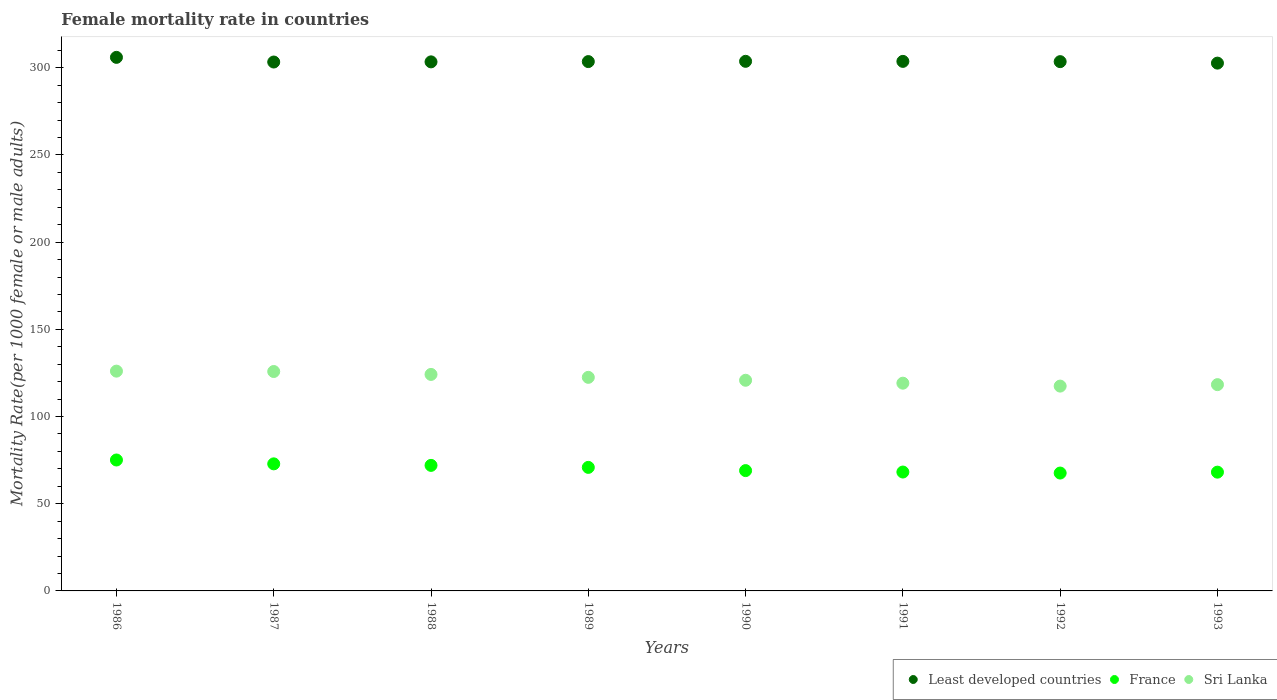What is the female mortality rate in France in 1993?
Provide a succinct answer. 68.11. Across all years, what is the maximum female mortality rate in Sri Lanka?
Offer a very short reply. 126.04. Across all years, what is the minimum female mortality rate in France?
Your answer should be very brief. 67.6. In which year was the female mortality rate in Least developed countries maximum?
Provide a succinct answer. 1986. What is the total female mortality rate in Least developed countries in the graph?
Your answer should be very brief. 2429.85. What is the difference between the female mortality rate in Sri Lanka in 1990 and that in 1991?
Offer a very short reply. 1.67. What is the difference between the female mortality rate in Least developed countries in 1993 and the female mortality rate in Sri Lanka in 1987?
Ensure brevity in your answer.  176.85. What is the average female mortality rate in Least developed countries per year?
Your response must be concise. 303.73. In the year 1991, what is the difference between the female mortality rate in Sri Lanka and female mortality rate in Least developed countries?
Ensure brevity in your answer.  -184.54. What is the ratio of the female mortality rate in France in 1988 to that in 1989?
Offer a very short reply. 1.02. Is the female mortality rate in France in 1986 less than that in 1989?
Provide a short and direct response. No. What is the difference between the highest and the second highest female mortality rate in Sri Lanka?
Make the answer very short. 0.21. What is the difference between the highest and the lowest female mortality rate in France?
Provide a short and direct response. 7.49. In how many years, is the female mortality rate in Sri Lanka greater than the average female mortality rate in Sri Lanka taken over all years?
Your answer should be compact. 4. Is the female mortality rate in France strictly greater than the female mortality rate in Least developed countries over the years?
Offer a terse response. No. How many years are there in the graph?
Your response must be concise. 8. What is the difference between two consecutive major ticks on the Y-axis?
Offer a terse response. 50. Are the values on the major ticks of Y-axis written in scientific E-notation?
Your answer should be compact. No. Does the graph contain grids?
Provide a short and direct response. No. Where does the legend appear in the graph?
Your response must be concise. Bottom right. How are the legend labels stacked?
Make the answer very short. Horizontal. What is the title of the graph?
Make the answer very short. Female mortality rate in countries. What is the label or title of the X-axis?
Make the answer very short. Years. What is the label or title of the Y-axis?
Your answer should be very brief. Mortality Rate(per 1000 female or male adults). What is the Mortality Rate(per 1000 female or male adults) in Least developed countries in 1986?
Your answer should be very brief. 305.98. What is the Mortality Rate(per 1000 female or male adults) of France in 1986?
Offer a very short reply. 75.09. What is the Mortality Rate(per 1000 female or male adults) of Sri Lanka in 1986?
Offer a terse response. 126.04. What is the Mortality Rate(per 1000 female or male adults) of Least developed countries in 1987?
Your answer should be compact. 303.31. What is the Mortality Rate(per 1000 female or male adults) in France in 1987?
Provide a short and direct response. 72.87. What is the Mortality Rate(per 1000 female or male adults) in Sri Lanka in 1987?
Give a very brief answer. 125.83. What is the Mortality Rate(per 1000 female or male adults) in Least developed countries in 1988?
Make the answer very short. 303.4. What is the Mortality Rate(per 1000 female or male adults) of France in 1988?
Your response must be concise. 72. What is the Mortality Rate(per 1000 female or male adults) of Sri Lanka in 1988?
Your answer should be compact. 124.15. What is the Mortality Rate(per 1000 female or male adults) in Least developed countries in 1989?
Give a very brief answer. 303.56. What is the Mortality Rate(per 1000 female or male adults) of France in 1989?
Your answer should be compact. 70.85. What is the Mortality Rate(per 1000 female or male adults) of Sri Lanka in 1989?
Give a very brief answer. 122.48. What is the Mortality Rate(per 1000 female or male adults) in Least developed countries in 1990?
Give a very brief answer. 303.71. What is the Mortality Rate(per 1000 female or male adults) of France in 1990?
Give a very brief answer. 69. What is the Mortality Rate(per 1000 female or male adults) of Sri Lanka in 1990?
Keep it short and to the point. 120.81. What is the Mortality Rate(per 1000 female or male adults) of Least developed countries in 1991?
Your answer should be compact. 303.68. What is the Mortality Rate(per 1000 female or male adults) in France in 1991?
Ensure brevity in your answer.  68.18. What is the Mortality Rate(per 1000 female or male adults) of Sri Lanka in 1991?
Provide a succinct answer. 119.13. What is the Mortality Rate(per 1000 female or male adults) of Least developed countries in 1992?
Offer a terse response. 303.53. What is the Mortality Rate(per 1000 female or male adults) in France in 1992?
Offer a very short reply. 67.6. What is the Mortality Rate(per 1000 female or male adults) in Sri Lanka in 1992?
Your answer should be compact. 117.46. What is the Mortality Rate(per 1000 female or male adults) of Least developed countries in 1993?
Your answer should be very brief. 302.68. What is the Mortality Rate(per 1000 female or male adults) of France in 1993?
Your response must be concise. 68.11. What is the Mortality Rate(per 1000 female or male adults) in Sri Lanka in 1993?
Keep it short and to the point. 118.3. Across all years, what is the maximum Mortality Rate(per 1000 female or male adults) in Least developed countries?
Make the answer very short. 305.98. Across all years, what is the maximum Mortality Rate(per 1000 female or male adults) of France?
Offer a terse response. 75.09. Across all years, what is the maximum Mortality Rate(per 1000 female or male adults) in Sri Lanka?
Provide a short and direct response. 126.04. Across all years, what is the minimum Mortality Rate(per 1000 female or male adults) of Least developed countries?
Offer a terse response. 302.68. Across all years, what is the minimum Mortality Rate(per 1000 female or male adults) in France?
Your response must be concise. 67.6. Across all years, what is the minimum Mortality Rate(per 1000 female or male adults) of Sri Lanka?
Your answer should be compact. 117.46. What is the total Mortality Rate(per 1000 female or male adults) in Least developed countries in the graph?
Give a very brief answer. 2429.85. What is the total Mortality Rate(per 1000 female or male adults) of France in the graph?
Make the answer very short. 563.69. What is the total Mortality Rate(per 1000 female or male adults) in Sri Lanka in the graph?
Make the answer very short. 974.2. What is the difference between the Mortality Rate(per 1000 female or male adults) in Least developed countries in 1986 and that in 1987?
Provide a short and direct response. 2.67. What is the difference between the Mortality Rate(per 1000 female or male adults) in France in 1986 and that in 1987?
Your answer should be compact. 2.22. What is the difference between the Mortality Rate(per 1000 female or male adults) in Sri Lanka in 1986 and that in 1987?
Make the answer very short. 0.21. What is the difference between the Mortality Rate(per 1000 female or male adults) in Least developed countries in 1986 and that in 1988?
Offer a very short reply. 2.58. What is the difference between the Mortality Rate(per 1000 female or male adults) of France in 1986 and that in 1988?
Offer a very short reply. 3.09. What is the difference between the Mortality Rate(per 1000 female or male adults) in Sri Lanka in 1986 and that in 1988?
Your answer should be compact. 1.89. What is the difference between the Mortality Rate(per 1000 female or male adults) in Least developed countries in 1986 and that in 1989?
Your answer should be compact. 2.43. What is the difference between the Mortality Rate(per 1000 female or male adults) of France in 1986 and that in 1989?
Your answer should be very brief. 4.24. What is the difference between the Mortality Rate(per 1000 female or male adults) of Sri Lanka in 1986 and that in 1989?
Keep it short and to the point. 3.56. What is the difference between the Mortality Rate(per 1000 female or male adults) of Least developed countries in 1986 and that in 1990?
Offer a very short reply. 2.27. What is the difference between the Mortality Rate(per 1000 female or male adults) of France in 1986 and that in 1990?
Make the answer very short. 6.09. What is the difference between the Mortality Rate(per 1000 female or male adults) in Sri Lanka in 1986 and that in 1990?
Offer a terse response. 5.23. What is the difference between the Mortality Rate(per 1000 female or male adults) of Least developed countries in 1986 and that in 1991?
Your answer should be compact. 2.31. What is the difference between the Mortality Rate(per 1000 female or male adults) in France in 1986 and that in 1991?
Ensure brevity in your answer.  6.91. What is the difference between the Mortality Rate(per 1000 female or male adults) of Sri Lanka in 1986 and that in 1991?
Make the answer very short. 6.91. What is the difference between the Mortality Rate(per 1000 female or male adults) in Least developed countries in 1986 and that in 1992?
Provide a succinct answer. 2.46. What is the difference between the Mortality Rate(per 1000 female or male adults) in France in 1986 and that in 1992?
Your response must be concise. 7.49. What is the difference between the Mortality Rate(per 1000 female or male adults) in Sri Lanka in 1986 and that in 1992?
Your answer should be very brief. 8.58. What is the difference between the Mortality Rate(per 1000 female or male adults) in Least developed countries in 1986 and that in 1993?
Provide a succinct answer. 3.31. What is the difference between the Mortality Rate(per 1000 female or male adults) in France in 1986 and that in 1993?
Ensure brevity in your answer.  6.97. What is the difference between the Mortality Rate(per 1000 female or male adults) in Sri Lanka in 1986 and that in 1993?
Your response must be concise. 7.74. What is the difference between the Mortality Rate(per 1000 female or male adults) of Least developed countries in 1987 and that in 1988?
Offer a very short reply. -0.09. What is the difference between the Mortality Rate(per 1000 female or male adults) of France in 1987 and that in 1988?
Your answer should be very brief. 0.87. What is the difference between the Mortality Rate(per 1000 female or male adults) of Sri Lanka in 1987 and that in 1988?
Offer a very short reply. 1.67. What is the difference between the Mortality Rate(per 1000 female or male adults) in Least developed countries in 1987 and that in 1989?
Offer a terse response. -0.25. What is the difference between the Mortality Rate(per 1000 female or male adults) of France in 1987 and that in 1989?
Provide a succinct answer. 2.02. What is the difference between the Mortality Rate(per 1000 female or male adults) in Sri Lanka in 1987 and that in 1989?
Your response must be concise. 3.35. What is the difference between the Mortality Rate(per 1000 female or male adults) of Least developed countries in 1987 and that in 1990?
Make the answer very short. -0.4. What is the difference between the Mortality Rate(per 1000 female or male adults) of France in 1987 and that in 1990?
Offer a very short reply. 3.87. What is the difference between the Mortality Rate(per 1000 female or male adults) of Sri Lanka in 1987 and that in 1990?
Your response must be concise. 5.02. What is the difference between the Mortality Rate(per 1000 female or male adults) in Least developed countries in 1987 and that in 1991?
Give a very brief answer. -0.37. What is the difference between the Mortality Rate(per 1000 female or male adults) of France in 1987 and that in 1991?
Make the answer very short. 4.69. What is the difference between the Mortality Rate(per 1000 female or male adults) of Sri Lanka in 1987 and that in 1991?
Keep it short and to the point. 6.69. What is the difference between the Mortality Rate(per 1000 female or male adults) in Least developed countries in 1987 and that in 1992?
Give a very brief answer. -0.22. What is the difference between the Mortality Rate(per 1000 female or male adults) of France in 1987 and that in 1992?
Your response must be concise. 5.27. What is the difference between the Mortality Rate(per 1000 female or male adults) in Sri Lanka in 1987 and that in 1992?
Give a very brief answer. 8.37. What is the difference between the Mortality Rate(per 1000 female or male adults) in Least developed countries in 1987 and that in 1993?
Provide a short and direct response. 0.63. What is the difference between the Mortality Rate(per 1000 female or male adults) in France in 1987 and that in 1993?
Your answer should be compact. 4.75. What is the difference between the Mortality Rate(per 1000 female or male adults) in Sri Lanka in 1987 and that in 1993?
Keep it short and to the point. 7.53. What is the difference between the Mortality Rate(per 1000 female or male adults) in Least developed countries in 1988 and that in 1989?
Make the answer very short. -0.15. What is the difference between the Mortality Rate(per 1000 female or male adults) in France in 1988 and that in 1989?
Provide a succinct answer. 1.15. What is the difference between the Mortality Rate(per 1000 female or male adults) of Sri Lanka in 1988 and that in 1989?
Give a very brief answer. 1.67. What is the difference between the Mortality Rate(per 1000 female or male adults) of Least developed countries in 1988 and that in 1990?
Make the answer very short. -0.31. What is the difference between the Mortality Rate(per 1000 female or male adults) of France in 1988 and that in 1990?
Offer a terse response. 2.99. What is the difference between the Mortality Rate(per 1000 female or male adults) in Sri Lanka in 1988 and that in 1990?
Give a very brief answer. 3.35. What is the difference between the Mortality Rate(per 1000 female or male adults) of Least developed countries in 1988 and that in 1991?
Provide a succinct answer. -0.27. What is the difference between the Mortality Rate(per 1000 female or male adults) in France in 1988 and that in 1991?
Your response must be concise. 3.81. What is the difference between the Mortality Rate(per 1000 female or male adults) in Sri Lanka in 1988 and that in 1991?
Your response must be concise. 5.02. What is the difference between the Mortality Rate(per 1000 female or male adults) in Least developed countries in 1988 and that in 1992?
Your answer should be compact. -0.13. What is the difference between the Mortality Rate(per 1000 female or male adults) of France in 1988 and that in 1992?
Keep it short and to the point. 4.4. What is the difference between the Mortality Rate(per 1000 female or male adults) of Sri Lanka in 1988 and that in 1992?
Your answer should be compact. 6.69. What is the difference between the Mortality Rate(per 1000 female or male adults) in Least developed countries in 1988 and that in 1993?
Ensure brevity in your answer.  0.72. What is the difference between the Mortality Rate(per 1000 female or male adults) of France in 1988 and that in 1993?
Keep it short and to the point. 3.88. What is the difference between the Mortality Rate(per 1000 female or male adults) of Sri Lanka in 1988 and that in 1993?
Offer a very short reply. 5.86. What is the difference between the Mortality Rate(per 1000 female or male adults) in Least developed countries in 1989 and that in 1990?
Offer a very short reply. -0.16. What is the difference between the Mortality Rate(per 1000 female or male adults) in France in 1989 and that in 1990?
Ensure brevity in your answer.  1.85. What is the difference between the Mortality Rate(per 1000 female or male adults) in Sri Lanka in 1989 and that in 1990?
Offer a very short reply. 1.67. What is the difference between the Mortality Rate(per 1000 female or male adults) in Least developed countries in 1989 and that in 1991?
Provide a succinct answer. -0.12. What is the difference between the Mortality Rate(per 1000 female or male adults) of France in 1989 and that in 1991?
Your answer should be compact. 2.67. What is the difference between the Mortality Rate(per 1000 female or male adults) of Sri Lanka in 1989 and that in 1991?
Keep it short and to the point. 3.35. What is the difference between the Mortality Rate(per 1000 female or male adults) in Least developed countries in 1989 and that in 1992?
Give a very brief answer. 0.03. What is the difference between the Mortality Rate(per 1000 female or male adults) of France in 1989 and that in 1992?
Your answer should be very brief. 3.25. What is the difference between the Mortality Rate(per 1000 female or male adults) in Sri Lanka in 1989 and that in 1992?
Make the answer very short. 5.02. What is the difference between the Mortality Rate(per 1000 female or male adults) in Least developed countries in 1989 and that in 1993?
Offer a very short reply. 0.88. What is the difference between the Mortality Rate(per 1000 female or male adults) in France in 1989 and that in 1993?
Provide a short and direct response. 2.73. What is the difference between the Mortality Rate(per 1000 female or male adults) of Sri Lanka in 1989 and that in 1993?
Provide a succinct answer. 4.18. What is the difference between the Mortality Rate(per 1000 female or male adults) in Least developed countries in 1990 and that in 1991?
Offer a very short reply. 0.04. What is the difference between the Mortality Rate(per 1000 female or male adults) of France in 1990 and that in 1991?
Your answer should be very brief. 0.82. What is the difference between the Mortality Rate(per 1000 female or male adults) in Sri Lanka in 1990 and that in 1991?
Your answer should be compact. 1.67. What is the difference between the Mortality Rate(per 1000 female or male adults) in Least developed countries in 1990 and that in 1992?
Ensure brevity in your answer.  0.19. What is the difference between the Mortality Rate(per 1000 female or male adults) in France in 1990 and that in 1992?
Ensure brevity in your answer.  1.4. What is the difference between the Mortality Rate(per 1000 female or male adults) in Sri Lanka in 1990 and that in 1992?
Make the answer very short. 3.35. What is the difference between the Mortality Rate(per 1000 female or male adults) of Least developed countries in 1990 and that in 1993?
Offer a terse response. 1.03. What is the difference between the Mortality Rate(per 1000 female or male adults) in France in 1990 and that in 1993?
Your answer should be compact. 0.89. What is the difference between the Mortality Rate(per 1000 female or male adults) of Sri Lanka in 1990 and that in 1993?
Make the answer very short. 2.51. What is the difference between the Mortality Rate(per 1000 female or male adults) of Least developed countries in 1991 and that in 1992?
Your answer should be compact. 0.15. What is the difference between the Mortality Rate(per 1000 female or male adults) in France in 1991 and that in 1992?
Your response must be concise. 0.58. What is the difference between the Mortality Rate(per 1000 female or male adults) of Sri Lanka in 1991 and that in 1992?
Your answer should be compact. 1.67. What is the difference between the Mortality Rate(per 1000 female or male adults) of France in 1991 and that in 1993?
Give a very brief answer. 0.07. What is the difference between the Mortality Rate(per 1000 female or male adults) in Sri Lanka in 1991 and that in 1993?
Make the answer very short. 0.84. What is the difference between the Mortality Rate(per 1000 female or male adults) of Least developed countries in 1992 and that in 1993?
Provide a succinct answer. 0.85. What is the difference between the Mortality Rate(per 1000 female or male adults) of France in 1992 and that in 1993?
Offer a very short reply. -0.52. What is the difference between the Mortality Rate(per 1000 female or male adults) in Sri Lanka in 1992 and that in 1993?
Your answer should be very brief. -0.83. What is the difference between the Mortality Rate(per 1000 female or male adults) in Least developed countries in 1986 and the Mortality Rate(per 1000 female or male adults) in France in 1987?
Offer a very short reply. 233.12. What is the difference between the Mortality Rate(per 1000 female or male adults) in Least developed countries in 1986 and the Mortality Rate(per 1000 female or male adults) in Sri Lanka in 1987?
Your response must be concise. 180.16. What is the difference between the Mortality Rate(per 1000 female or male adults) of France in 1986 and the Mortality Rate(per 1000 female or male adults) of Sri Lanka in 1987?
Your answer should be very brief. -50.74. What is the difference between the Mortality Rate(per 1000 female or male adults) in Least developed countries in 1986 and the Mortality Rate(per 1000 female or male adults) in France in 1988?
Keep it short and to the point. 233.99. What is the difference between the Mortality Rate(per 1000 female or male adults) in Least developed countries in 1986 and the Mortality Rate(per 1000 female or male adults) in Sri Lanka in 1988?
Provide a succinct answer. 181.83. What is the difference between the Mortality Rate(per 1000 female or male adults) in France in 1986 and the Mortality Rate(per 1000 female or male adults) in Sri Lanka in 1988?
Your answer should be very brief. -49.07. What is the difference between the Mortality Rate(per 1000 female or male adults) of Least developed countries in 1986 and the Mortality Rate(per 1000 female or male adults) of France in 1989?
Offer a terse response. 235.14. What is the difference between the Mortality Rate(per 1000 female or male adults) in Least developed countries in 1986 and the Mortality Rate(per 1000 female or male adults) in Sri Lanka in 1989?
Make the answer very short. 183.5. What is the difference between the Mortality Rate(per 1000 female or male adults) in France in 1986 and the Mortality Rate(per 1000 female or male adults) in Sri Lanka in 1989?
Your answer should be compact. -47.39. What is the difference between the Mortality Rate(per 1000 female or male adults) of Least developed countries in 1986 and the Mortality Rate(per 1000 female or male adults) of France in 1990?
Your response must be concise. 236.98. What is the difference between the Mortality Rate(per 1000 female or male adults) in Least developed countries in 1986 and the Mortality Rate(per 1000 female or male adults) in Sri Lanka in 1990?
Provide a succinct answer. 185.18. What is the difference between the Mortality Rate(per 1000 female or male adults) of France in 1986 and the Mortality Rate(per 1000 female or male adults) of Sri Lanka in 1990?
Offer a terse response. -45.72. What is the difference between the Mortality Rate(per 1000 female or male adults) of Least developed countries in 1986 and the Mortality Rate(per 1000 female or male adults) of France in 1991?
Offer a very short reply. 237.8. What is the difference between the Mortality Rate(per 1000 female or male adults) in Least developed countries in 1986 and the Mortality Rate(per 1000 female or male adults) in Sri Lanka in 1991?
Keep it short and to the point. 186.85. What is the difference between the Mortality Rate(per 1000 female or male adults) of France in 1986 and the Mortality Rate(per 1000 female or male adults) of Sri Lanka in 1991?
Ensure brevity in your answer.  -44.05. What is the difference between the Mortality Rate(per 1000 female or male adults) of Least developed countries in 1986 and the Mortality Rate(per 1000 female or male adults) of France in 1992?
Give a very brief answer. 238.39. What is the difference between the Mortality Rate(per 1000 female or male adults) of Least developed countries in 1986 and the Mortality Rate(per 1000 female or male adults) of Sri Lanka in 1992?
Provide a short and direct response. 188.52. What is the difference between the Mortality Rate(per 1000 female or male adults) in France in 1986 and the Mortality Rate(per 1000 female or male adults) in Sri Lanka in 1992?
Your response must be concise. -42.37. What is the difference between the Mortality Rate(per 1000 female or male adults) of Least developed countries in 1986 and the Mortality Rate(per 1000 female or male adults) of France in 1993?
Your answer should be compact. 237.87. What is the difference between the Mortality Rate(per 1000 female or male adults) of Least developed countries in 1986 and the Mortality Rate(per 1000 female or male adults) of Sri Lanka in 1993?
Make the answer very short. 187.69. What is the difference between the Mortality Rate(per 1000 female or male adults) in France in 1986 and the Mortality Rate(per 1000 female or male adults) in Sri Lanka in 1993?
Keep it short and to the point. -43.21. What is the difference between the Mortality Rate(per 1000 female or male adults) of Least developed countries in 1987 and the Mortality Rate(per 1000 female or male adults) of France in 1988?
Offer a terse response. 231.32. What is the difference between the Mortality Rate(per 1000 female or male adults) in Least developed countries in 1987 and the Mortality Rate(per 1000 female or male adults) in Sri Lanka in 1988?
Offer a very short reply. 179.16. What is the difference between the Mortality Rate(per 1000 female or male adults) of France in 1987 and the Mortality Rate(per 1000 female or male adults) of Sri Lanka in 1988?
Make the answer very short. -51.28. What is the difference between the Mortality Rate(per 1000 female or male adults) of Least developed countries in 1987 and the Mortality Rate(per 1000 female or male adults) of France in 1989?
Make the answer very short. 232.46. What is the difference between the Mortality Rate(per 1000 female or male adults) in Least developed countries in 1987 and the Mortality Rate(per 1000 female or male adults) in Sri Lanka in 1989?
Your answer should be compact. 180.83. What is the difference between the Mortality Rate(per 1000 female or male adults) in France in 1987 and the Mortality Rate(per 1000 female or male adults) in Sri Lanka in 1989?
Your answer should be compact. -49.61. What is the difference between the Mortality Rate(per 1000 female or male adults) of Least developed countries in 1987 and the Mortality Rate(per 1000 female or male adults) of France in 1990?
Provide a short and direct response. 234.31. What is the difference between the Mortality Rate(per 1000 female or male adults) in Least developed countries in 1987 and the Mortality Rate(per 1000 female or male adults) in Sri Lanka in 1990?
Offer a terse response. 182.5. What is the difference between the Mortality Rate(per 1000 female or male adults) of France in 1987 and the Mortality Rate(per 1000 female or male adults) of Sri Lanka in 1990?
Provide a short and direct response. -47.94. What is the difference between the Mortality Rate(per 1000 female or male adults) of Least developed countries in 1987 and the Mortality Rate(per 1000 female or male adults) of France in 1991?
Offer a very short reply. 235.13. What is the difference between the Mortality Rate(per 1000 female or male adults) in Least developed countries in 1987 and the Mortality Rate(per 1000 female or male adults) in Sri Lanka in 1991?
Keep it short and to the point. 184.18. What is the difference between the Mortality Rate(per 1000 female or male adults) in France in 1987 and the Mortality Rate(per 1000 female or male adults) in Sri Lanka in 1991?
Provide a succinct answer. -46.27. What is the difference between the Mortality Rate(per 1000 female or male adults) of Least developed countries in 1987 and the Mortality Rate(per 1000 female or male adults) of France in 1992?
Provide a short and direct response. 235.71. What is the difference between the Mortality Rate(per 1000 female or male adults) of Least developed countries in 1987 and the Mortality Rate(per 1000 female or male adults) of Sri Lanka in 1992?
Make the answer very short. 185.85. What is the difference between the Mortality Rate(per 1000 female or male adults) in France in 1987 and the Mortality Rate(per 1000 female or male adults) in Sri Lanka in 1992?
Provide a short and direct response. -44.59. What is the difference between the Mortality Rate(per 1000 female or male adults) in Least developed countries in 1987 and the Mortality Rate(per 1000 female or male adults) in France in 1993?
Give a very brief answer. 235.2. What is the difference between the Mortality Rate(per 1000 female or male adults) of Least developed countries in 1987 and the Mortality Rate(per 1000 female or male adults) of Sri Lanka in 1993?
Provide a short and direct response. 185.01. What is the difference between the Mortality Rate(per 1000 female or male adults) in France in 1987 and the Mortality Rate(per 1000 female or male adults) in Sri Lanka in 1993?
Give a very brief answer. -45.43. What is the difference between the Mortality Rate(per 1000 female or male adults) in Least developed countries in 1988 and the Mortality Rate(per 1000 female or male adults) in France in 1989?
Keep it short and to the point. 232.55. What is the difference between the Mortality Rate(per 1000 female or male adults) in Least developed countries in 1988 and the Mortality Rate(per 1000 female or male adults) in Sri Lanka in 1989?
Offer a terse response. 180.92. What is the difference between the Mortality Rate(per 1000 female or male adults) of France in 1988 and the Mortality Rate(per 1000 female or male adults) of Sri Lanka in 1989?
Ensure brevity in your answer.  -50.48. What is the difference between the Mortality Rate(per 1000 female or male adults) in Least developed countries in 1988 and the Mortality Rate(per 1000 female or male adults) in France in 1990?
Provide a short and direct response. 234.4. What is the difference between the Mortality Rate(per 1000 female or male adults) in Least developed countries in 1988 and the Mortality Rate(per 1000 female or male adults) in Sri Lanka in 1990?
Offer a very short reply. 182.6. What is the difference between the Mortality Rate(per 1000 female or male adults) in France in 1988 and the Mortality Rate(per 1000 female or male adults) in Sri Lanka in 1990?
Provide a succinct answer. -48.81. What is the difference between the Mortality Rate(per 1000 female or male adults) of Least developed countries in 1988 and the Mortality Rate(per 1000 female or male adults) of France in 1991?
Offer a terse response. 235.22. What is the difference between the Mortality Rate(per 1000 female or male adults) of Least developed countries in 1988 and the Mortality Rate(per 1000 female or male adults) of Sri Lanka in 1991?
Offer a terse response. 184.27. What is the difference between the Mortality Rate(per 1000 female or male adults) in France in 1988 and the Mortality Rate(per 1000 female or male adults) in Sri Lanka in 1991?
Keep it short and to the point. -47.14. What is the difference between the Mortality Rate(per 1000 female or male adults) of Least developed countries in 1988 and the Mortality Rate(per 1000 female or male adults) of France in 1992?
Provide a short and direct response. 235.81. What is the difference between the Mortality Rate(per 1000 female or male adults) of Least developed countries in 1988 and the Mortality Rate(per 1000 female or male adults) of Sri Lanka in 1992?
Offer a very short reply. 185.94. What is the difference between the Mortality Rate(per 1000 female or male adults) in France in 1988 and the Mortality Rate(per 1000 female or male adults) in Sri Lanka in 1992?
Keep it short and to the point. -45.47. What is the difference between the Mortality Rate(per 1000 female or male adults) in Least developed countries in 1988 and the Mortality Rate(per 1000 female or male adults) in France in 1993?
Give a very brief answer. 235.29. What is the difference between the Mortality Rate(per 1000 female or male adults) of Least developed countries in 1988 and the Mortality Rate(per 1000 female or male adults) of Sri Lanka in 1993?
Provide a short and direct response. 185.11. What is the difference between the Mortality Rate(per 1000 female or male adults) in France in 1988 and the Mortality Rate(per 1000 female or male adults) in Sri Lanka in 1993?
Offer a terse response. -46.3. What is the difference between the Mortality Rate(per 1000 female or male adults) in Least developed countries in 1989 and the Mortality Rate(per 1000 female or male adults) in France in 1990?
Provide a succinct answer. 234.56. What is the difference between the Mortality Rate(per 1000 female or male adults) of Least developed countries in 1989 and the Mortality Rate(per 1000 female or male adults) of Sri Lanka in 1990?
Offer a very short reply. 182.75. What is the difference between the Mortality Rate(per 1000 female or male adults) in France in 1989 and the Mortality Rate(per 1000 female or male adults) in Sri Lanka in 1990?
Your response must be concise. -49.96. What is the difference between the Mortality Rate(per 1000 female or male adults) in Least developed countries in 1989 and the Mortality Rate(per 1000 female or male adults) in France in 1991?
Offer a very short reply. 235.38. What is the difference between the Mortality Rate(per 1000 female or male adults) in Least developed countries in 1989 and the Mortality Rate(per 1000 female or male adults) in Sri Lanka in 1991?
Provide a short and direct response. 184.42. What is the difference between the Mortality Rate(per 1000 female or male adults) of France in 1989 and the Mortality Rate(per 1000 female or male adults) of Sri Lanka in 1991?
Your response must be concise. -48.28. What is the difference between the Mortality Rate(per 1000 female or male adults) in Least developed countries in 1989 and the Mortality Rate(per 1000 female or male adults) in France in 1992?
Offer a very short reply. 235.96. What is the difference between the Mortality Rate(per 1000 female or male adults) of Least developed countries in 1989 and the Mortality Rate(per 1000 female or male adults) of Sri Lanka in 1992?
Your answer should be very brief. 186.1. What is the difference between the Mortality Rate(per 1000 female or male adults) of France in 1989 and the Mortality Rate(per 1000 female or male adults) of Sri Lanka in 1992?
Provide a succinct answer. -46.61. What is the difference between the Mortality Rate(per 1000 female or male adults) in Least developed countries in 1989 and the Mortality Rate(per 1000 female or male adults) in France in 1993?
Your response must be concise. 235.44. What is the difference between the Mortality Rate(per 1000 female or male adults) in Least developed countries in 1989 and the Mortality Rate(per 1000 female or male adults) in Sri Lanka in 1993?
Offer a terse response. 185.26. What is the difference between the Mortality Rate(per 1000 female or male adults) of France in 1989 and the Mortality Rate(per 1000 female or male adults) of Sri Lanka in 1993?
Ensure brevity in your answer.  -47.45. What is the difference between the Mortality Rate(per 1000 female or male adults) in Least developed countries in 1990 and the Mortality Rate(per 1000 female or male adults) in France in 1991?
Your answer should be compact. 235.53. What is the difference between the Mortality Rate(per 1000 female or male adults) in Least developed countries in 1990 and the Mortality Rate(per 1000 female or male adults) in Sri Lanka in 1991?
Your answer should be compact. 184.58. What is the difference between the Mortality Rate(per 1000 female or male adults) in France in 1990 and the Mortality Rate(per 1000 female or male adults) in Sri Lanka in 1991?
Give a very brief answer. -50.13. What is the difference between the Mortality Rate(per 1000 female or male adults) of Least developed countries in 1990 and the Mortality Rate(per 1000 female or male adults) of France in 1992?
Offer a very short reply. 236.12. What is the difference between the Mortality Rate(per 1000 female or male adults) of Least developed countries in 1990 and the Mortality Rate(per 1000 female or male adults) of Sri Lanka in 1992?
Make the answer very short. 186.25. What is the difference between the Mortality Rate(per 1000 female or male adults) in France in 1990 and the Mortality Rate(per 1000 female or male adults) in Sri Lanka in 1992?
Make the answer very short. -48.46. What is the difference between the Mortality Rate(per 1000 female or male adults) of Least developed countries in 1990 and the Mortality Rate(per 1000 female or male adults) of France in 1993?
Your answer should be very brief. 235.6. What is the difference between the Mortality Rate(per 1000 female or male adults) in Least developed countries in 1990 and the Mortality Rate(per 1000 female or male adults) in Sri Lanka in 1993?
Offer a very short reply. 185.42. What is the difference between the Mortality Rate(per 1000 female or male adults) in France in 1990 and the Mortality Rate(per 1000 female or male adults) in Sri Lanka in 1993?
Offer a very short reply. -49.29. What is the difference between the Mortality Rate(per 1000 female or male adults) of Least developed countries in 1991 and the Mortality Rate(per 1000 female or male adults) of France in 1992?
Your answer should be compact. 236.08. What is the difference between the Mortality Rate(per 1000 female or male adults) in Least developed countries in 1991 and the Mortality Rate(per 1000 female or male adults) in Sri Lanka in 1992?
Offer a terse response. 186.22. What is the difference between the Mortality Rate(per 1000 female or male adults) of France in 1991 and the Mortality Rate(per 1000 female or male adults) of Sri Lanka in 1992?
Ensure brevity in your answer.  -49.28. What is the difference between the Mortality Rate(per 1000 female or male adults) in Least developed countries in 1991 and the Mortality Rate(per 1000 female or male adults) in France in 1993?
Ensure brevity in your answer.  235.56. What is the difference between the Mortality Rate(per 1000 female or male adults) in Least developed countries in 1991 and the Mortality Rate(per 1000 female or male adults) in Sri Lanka in 1993?
Ensure brevity in your answer.  185.38. What is the difference between the Mortality Rate(per 1000 female or male adults) of France in 1991 and the Mortality Rate(per 1000 female or male adults) of Sri Lanka in 1993?
Keep it short and to the point. -50.12. What is the difference between the Mortality Rate(per 1000 female or male adults) in Least developed countries in 1992 and the Mortality Rate(per 1000 female or male adults) in France in 1993?
Keep it short and to the point. 235.41. What is the difference between the Mortality Rate(per 1000 female or male adults) in Least developed countries in 1992 and the Mortality Rate(per 1000 female or male adults) in Sri Lanka in 1993?
Your response must be concise. 185.23. What is the difference between the Mortality Rate(per 1000 female or male adults) in France in 1992 and the Mortality Rate(per 1000 female or male adults) in Sri Lanka in 1993?
Your answer should be very brief. -50.7. What is the average Mortality Rate(per 1000 female or male adults) in Least developed countries per year?
Provide a short and direct response. 303.73. What is the average Mortality Rate(per 1000 female or male adults) in France per year?
Keep it short and to the point. 70.46. What is the average Mortality Rate(per 1000 female or male adults) of Sri Lanka per year?
Make the answer very short. 121.77. In the year 1986, what is the difference between the Mortality Rate(per 1000 female or male adults) of Least developed countries and Mortality Rate(per 1000 female or male adults) of France?
Give a very brief answer. 230.9. In the year 1986, what is the difference between the Mortality Rate(per 1000 female or male adults) in Least developed countries and Mortality Rate(per 1000 female or male adults) in Sri Lanka?
Provide a short and direct response. 179.95. In the year 1986, what is the difference between the Mortality Rate(per 1000 female or male adults) of France and Mortality Rate(per 1000 female or male adults) of Sri Lanka?
Provide a short and direct response. -50.95. In the year 1987, what is the difference between the Mortality Rate(per 1000 female or male adults) of Least developed countries and Mortality Rate(per 1000 female or male adults) of France?
Provide a succinct answer. 230.44. In the year 1987, what is the difference between the Mortality Rate(per 1000 female or male adults) of Least developed countries and Mortality Rate(per 1000 female or male adults) of Sri Lanka?
Make the answer very short. 177.48. In the year 1987, what is the difference between the Mortality Rate(per 1000 female or male adults) of France and Mortality Rate(per 1000 female or male adults) of Sri Lanka?
Give a very brief answer. -52.96. In the year 1988, what is the difference between the Mortality Rate(per 1000 female or male adults) in Least developed countries and Mortality Rate(per 1000 female or male adults) in France?
Make the answer very short. 231.41. In the year 1988, what is the difference between the Mortality Rate(per 1000 female or male adults) in Least developed countries and Mortality Rate(per 1000 female or male adults) in Sri Lanka?
Give a very brief answer. 179.25. In the year 1988, what is the difference between the Mortality Rate(per 1000 female or male adults) of France and Mortality Rate(per 1000 female or male adults) of Sri Lanka?
Provide a succinct answer. -52.16. In the year 1989, what is the difference between the Mortality Rate(per 1000 female or male adults) of Least developed countries and Mortality Rate(per 1000 female or male adults) of France?
Ensure brevity in your answer.  232.71. In the year 1989, what is the difference between the Mortality Rate(per 1000 female or male adults) of Least developed countries and Mortality Rate(per 1000 female or male adults) of Sri Lanka?
Your response must be concise. 181.08. In the year 1989, what is the difference between the Mortality Rate(per 1000 female or male adults) in France and Mortality Rate(per 1000 female or male adults) in Sri Lanka?
Provide a succinct answer. -51.63. In the year 1990, what is the difference between the Mortality Rate(per 1000 female or male adults) in Least developed countries and Mortality Rate(per 1000 female or male adults) in France?
Your answer should be compact. 234.71. In the year 1990, what is the difference between the Mortality Rate(per 1000 female or male adults) in Least developed countries and Mortality Rate(per 1000 female or male adults) in Sri Lanka?
Keep it short and to the point. 182.91. In the year 1990, what is the difference between the Mortality Rate(per 1000 female or male adults) in France and Mortality Rate(per 1000 female or male adults) in Sri Lanka?
Your answer should be very brief. -51.81. In the year 1991, what is the difference between the Mortality Rate(per 1000 female or male adults) in Least developed countries and Mortality Rate(per 1000 female or male adults) in France?
Give a very brief answer. 235.5. In the year 1991, what is the difference between the Mortality Rate(per 1000 female or male adults) in Least developed countries and Mortality Rate(per 1000 female or male adults) in Sri Lanka?
Your answer should be compact. 184.54. In the year 1991, what is the difference between the Mortality Rate(per 1000 female or male adults) in France and Mortality Rate(per 1000 female or male adults) in Sri Lanka?
Your response must be concise. -50.95. In the year 1992, what is the difference between the Mortality Rate(per 1000 female or male adults) in Least developed countries and Mortality Rate(per 1000 female or male adults) in France?
Ensure brevity in your answer.  235.93. In the year 1992, what is the difference between the Mortality Rate(per 1000 female or male adults) in Least developed countries and Mortality Rate(per 1000 female or male adults) in Sri Lanka?
Provide a succinct answer. 186.07. In the year 1992, what is the difference between the Mortality Rate(per 1000 female or male adults) of France and Mortality Rate(per 1000 female or male adults) of Sri Lanka?
Offer a very short reply. -49.86. In the year 1993, what is the difference between the Mortality Rate(per 1000 female or male adults) in Least developed countries and Mortality Rate(per 1000 female or male adults) in France?
Give a very brief answer. 234.56. In the year 1993, what is the difference between the Mortality Rate(per 1000 female or male adults) in Least developed countries and Mortality Rate(per 1000 female or male adults) in Sri Lanka?
Your response must be concise. 184.38. In the year 1993, what is the difference between the Mortality Rate(per 1000 female or male adults) in France and Mortality Rate(per 1000 female or male adults) in Sri Lanka?
Make the answer very short. -50.18. What is the ratio of the Mortality Rate(per 1000 female or male adults) in Least developed countries in 1986 to that in 1987?
Your answer should be very brief. 1.01. What is the ratio of the Mortality Rate(per 1000 female or male adults) in France in 1986 to that in 1987?
Offer a terse response. 1.03. What is the ratio of the Mortality Rate(per 1000 female or male adults) in Least developed countries in 1986 to that in 1988?
Offer a very short reply. 1.01. What is the ratio of the Mortality Rate(per 1000 female or male adults) of France in 1986 to that in 1988?
Your response must be concise. 1.04. What is the ratio of the Mortality Rate(per 1000 female or male adults) in Sri Lanka in 1986 to that in 1988?
Provide a short and direct response. 1.02. What is the ratio of the Mortality Rate(per 1000 female or male adults) in France in 1986 to that in 1989?
Your response must be concise. 1.06. What is the ratio of the Mortality Rate(per 1000 female or male adults) of Sri Lanka in 1986 to that in 1989?
Keep it short and to the point. 1.03. What is the ratio of the Mortality Rate(per 1000 female or male adults) of Least developed countries in 1986 to that in 1990?
Offer a terse response. 1.01. What is the ratio of the Mortality Rate(per 1000 female or male adults) in France in 1986 to that in 1990?
Make the answer very short. 1.09. What is the ratio of the Mortality Rate(per 1000 female or male adults) of Sri Lanka in 1986 to that in 1990?
Keep it short and to the point. 1.04. What is the ratio of the Mortality Rate(per 1000 female or male adults) of Least developed countries in 1986 to that in 1991?
Your response must be concise. 1.01. What is the ratio of the Mortality Rate(per 1000 female or male adults) of France in 1986 to that in 1991?
Ensure brevity in your answer.  1.1. What is the ratio of the Mortality Rate(per 1000 female or male adults) of Sri Lanka in 1986 to that in 1991?
Provide a succinct answer. 1.06. What is the ratio of the Mortality Rate(per 1000 female or male adults) in France in 1986 to that in 1992?
Ensure brevity in your answer.  1.11. What is the ratio of the Mortality Rate(per 1000 female or male adults) in Sri Lanka in 1986 to that in 1992?
Your response must be concise. 1.07. What is the ratio of the Mortality Rate(per 1000 female or male adults) of Least developed countries in 1986 to that in 1993?
Provide a succinct answer. 1.01. What is the ratio of the Mortality Rate(per 1000 female or male adults) of France in 1986 to that in 1993?
Your answer should be compact. 1.1. What is the ratio of the Mortality Rate(per 1000 female or male adults) in Sri Lanka in 1986 to that in 1993?
Give a very brief answer. 1.07. What is the ratio of the Mortality Rate(per 1000 female or male adults) in France in 1987 to that in 1988?
Provide a succinct answer. 1.01. What is the ratio of the Mortality Rate(per 1000 female or male adults) of Sri Lanka in 1987 to that in 1988?
Offer a terse response. 1.01. What is the ratio of the Mortality Rate(per 1000 female or male adults) in France in 1987 to that in 1989?
Give a very brief answer. 1.03. What is the ratio of the Mortality Rate(per 1000 female or male adults) in Sri Lanka in 1987 to that in 1989?
Your answer should be very brief. 1.03. What is the ratio of the Mortality Rate(per 1000 female or male adults) in Least developed countries in 1987 to that in 1990?
Make the answer very short. 1. What is the ratio of the Mortality Rate(per 1000 female or male adults) in France in 1987 to that in 1990?
Your answer should be compact. 1.06. What is the ratio of the Mortality Rate(per 1000 female or male adults) of Sri Lanka in 1987 to that in 1990?
Offer a very short reply. 1.04. What is the ratio of the Mortality Rate(per 1000 female or male adults) in France in 1987 to that in 1991?
Your response must be concise. 1.07. What is the ratio of the Mortality Rate(per 1000 female or male adults) of Sri Lanka in 1987 to that in 1991?
Ensure brevity in your answer.  1.06. What is the ratio of the Mortality Rate(per 1000 female or male adults) of France in 1987 to that in 1992?
Make the answer very short. 1.08. What is the ratio of the Mortality Rate(per 1000 female or male adults) of Sri Lanka in 1987 to that in 1992?
Your answer should be very brief. 1.07. What is the ratio of the Mortality Rate(per 1000 female or male adults) in Least developed countries in 1987 to that in 1993?
Your answer should be compact. 1. What is the ratio of the Mortality Rate(per 1000 female or male adults) of France in 1987 to that in 1993?
Keep it short and to the point. 1.07. What is the ratio of the Mortality Rate(per 1000 female or male adults) in Sri Lanka in 1987 to that in 1993?
Make the answer very short. 1.06. What is the ratio of the Mortality Rate(per 1000 female or male adults) of France in 1988 to that in 1989?
Give a very brief answer. 1.02. What is the ratio of the Mortality Rate(per 1000 female or male adults) of Sri Lanka in 1988 to that in 1989?
Provide a succinct answer. 1.01. What is the ratio of the Mortality Rate(per 1000 female or male adults) of Least developed countries in 1988 to that in 1990?
Your answer should be compact. 1. What is the ratio of the Mortality Rate(per 1000 female or male adults) of France in 1988 to that in 1990?
Your answer should be compact. 1.04. What is the ratio of the Mortality Rate(per 1000 female or male adults) in Sri Lanka in 1988 to that in 1990?
Make the answer very short. 1.03. What is the ratio of the Mortality Rate(per 1000 female or male adults) in Least developed countries in 1988 to that in 1991?
Make the answer very short. 1. What is the ratio of the Mortality Rate(per 1000 female or male adults) of France in 1988 to that in 1991?
Provide a succinct answer. 1.06. What is the ratio of the Mortality Rate(per 1000 female or male adults) in Sri Lanka in 1988 to that in 1991?
Your answer should be compact. 1.04. What is the ratio of the Mortality Rate(per 1000 female or male adults) in France in 1988 to that in 1992?
Your response must be concise. 1.07. What is the ratio of the Mortality Rate(per 1000 female or male adults) in Sri Lanka in 1988 to that in 1992?
Provide a succinct answer. 1.06. What is the ratio of the Mortality Rate(per 1000 female or male adults) in France in 1988 to that in 1993?
Your answer should be compact. 1.06. What is the ratio of the Mortality Rate(per 1000 female or male adults) in Sri Lanka in 1988 to that in 1993?
Provide a short and direct response. 1.05. What is the ratio of the Mortality Rate(per 1000 female or male adults) of Least developed countries in 1989 to that in 1990?
Keep it short and to the point. 1. What is the ratio of the Mortality Rate(per 1000 female or male adults) of France in 1989 to that in 1990?
Your response must be concise. 1.03. What is the ratio of the Mortality Rate(per 1000 female or male adults) of Sri Lanka in 1989 to that in 1990?
Your answer should be very brief. 1.01. What is the ratio of the Mortality Rate(per 1000 female or male adults) in Least developed countries in 1989 to that in 1991?
Ensure brevity in your answer.  1. What is the ratio of the Mortality Rate(per 1000 female or male adults) of France in 1989 to that in 1991?
Offer a very short reply. 1.04. What is the ratio of the Mortality Rate(per 1000 female or male adults) of Sri Lanka in 1989 to that in 1991?
Offer a terse response. 1.03. What is the ratio of the Mortality Rate(per 1000 female or male adults) in Least developed countries in 1989 to that in 1992?
Provide a short and direct response. 1. What is the ratio of the Mortality Rate(per 1000 female or male adults) of France in 1989 to that in 1992?
Make the answer very short. 1.05. What is the ratio of the Mortality Rate(per 1000 female or male adults) of Sri Lanka in 1989 to that in 1992?
Ensure brevity in your answer.  1.04. What is the ratio of the Mortality Rate(per 1000 female or male adults) in France in 1989 to that in 1993?
Ensure brevity in your answer.  1.04. What is the ratio of the Mortality Rate(per 1000 female or male adults) of Sri Lanka in 1989 to that in 1993?
Offer a very short reply. 1.04. What is the ratio of the Mortality Rate(per 1000 female or male adults) in Least developed countries in 1990 to that in 1991?
Ensure brevity in your answer.  1. What is the ratio of the Mortality Rate(per 1000 female or male adults) in France in 1990 to that in 1991?
Offer a very short reply. 1.01. What is the ratio of the Mortality Rate(per 1000 female or male adults) in Sri Lanka in 1990 to that in 1991?
Your answer should be compact. 1.01. What is the ratio of the Mortality Rate(per 1000 female or male adults) in France in 1990 to that in 1992?
Your answer should be very brief. 1.02. What is the ratio of the Mortality Rate(per 1000 female or male adults) in Sri Lanka in 1990 to that in 1992?
Provide a succinct answer. 1.03. What is the ratio of the Mortality Rate(per 1000 female or male adults) in France in 1990 to that in 1993?
Offer a terse response. 1.01. What is the ratio of the Mortality Rate(per 1000 female or male adults) of Sri Lanka in 1990 to that in 1993?
Make the answer very short. 1.02. What is the ratio of the Mortality Rate(per 1000 female or male adults) of France in 1991 to that in 1992?
Your answer should be very brief. 1.01. What is the ratio of the Mortality Rate(per 1000 female or male adults) of Sri Lanka in 1991 to that in 1992?
Ensure brevity in your answer.  1.01. What is the ratio of the Mortality Rate(per 1000 female or male adults) of Sri Lanka in 1991 to that in 1993?
Provide a succinct answer. 1.01. What is the ratio of the Mortality Rate(per 1000 female or male adults) in Sri Lanka in 1992 to that in 1993?
Offer a terse response. 0.99. What is the difference between the highest and the second highest Mortality Rate(per 1000 female or male adults) of Least developed countries?
Keep it short and to the point. 2.27. What is the difference between the highest and the second highest Mortality Rate(per 1000 female or male adults) of France?
Provide a succinct answer. 2.22. What is the difference between the highest and the second highest Mortality Rate(per 1000 female or male adults) of Sri Lanka?
Keep it short and to the point. 0.21. What is the difference between the highest and the lowest Mortality Rate(per 1000 female or male adults) of Least developed countries?
Your response must be concise. 3.31. What is the difference between the highest and the lowest Mortality Rate(per 1000 female or male adults) in France?
Make the answer very short. 7.49. What is the difference between the highest and the lowest Mortality Rate(per 1000 female or male adults) in Sri Lanka?
Offer a terse response. 8.58. 